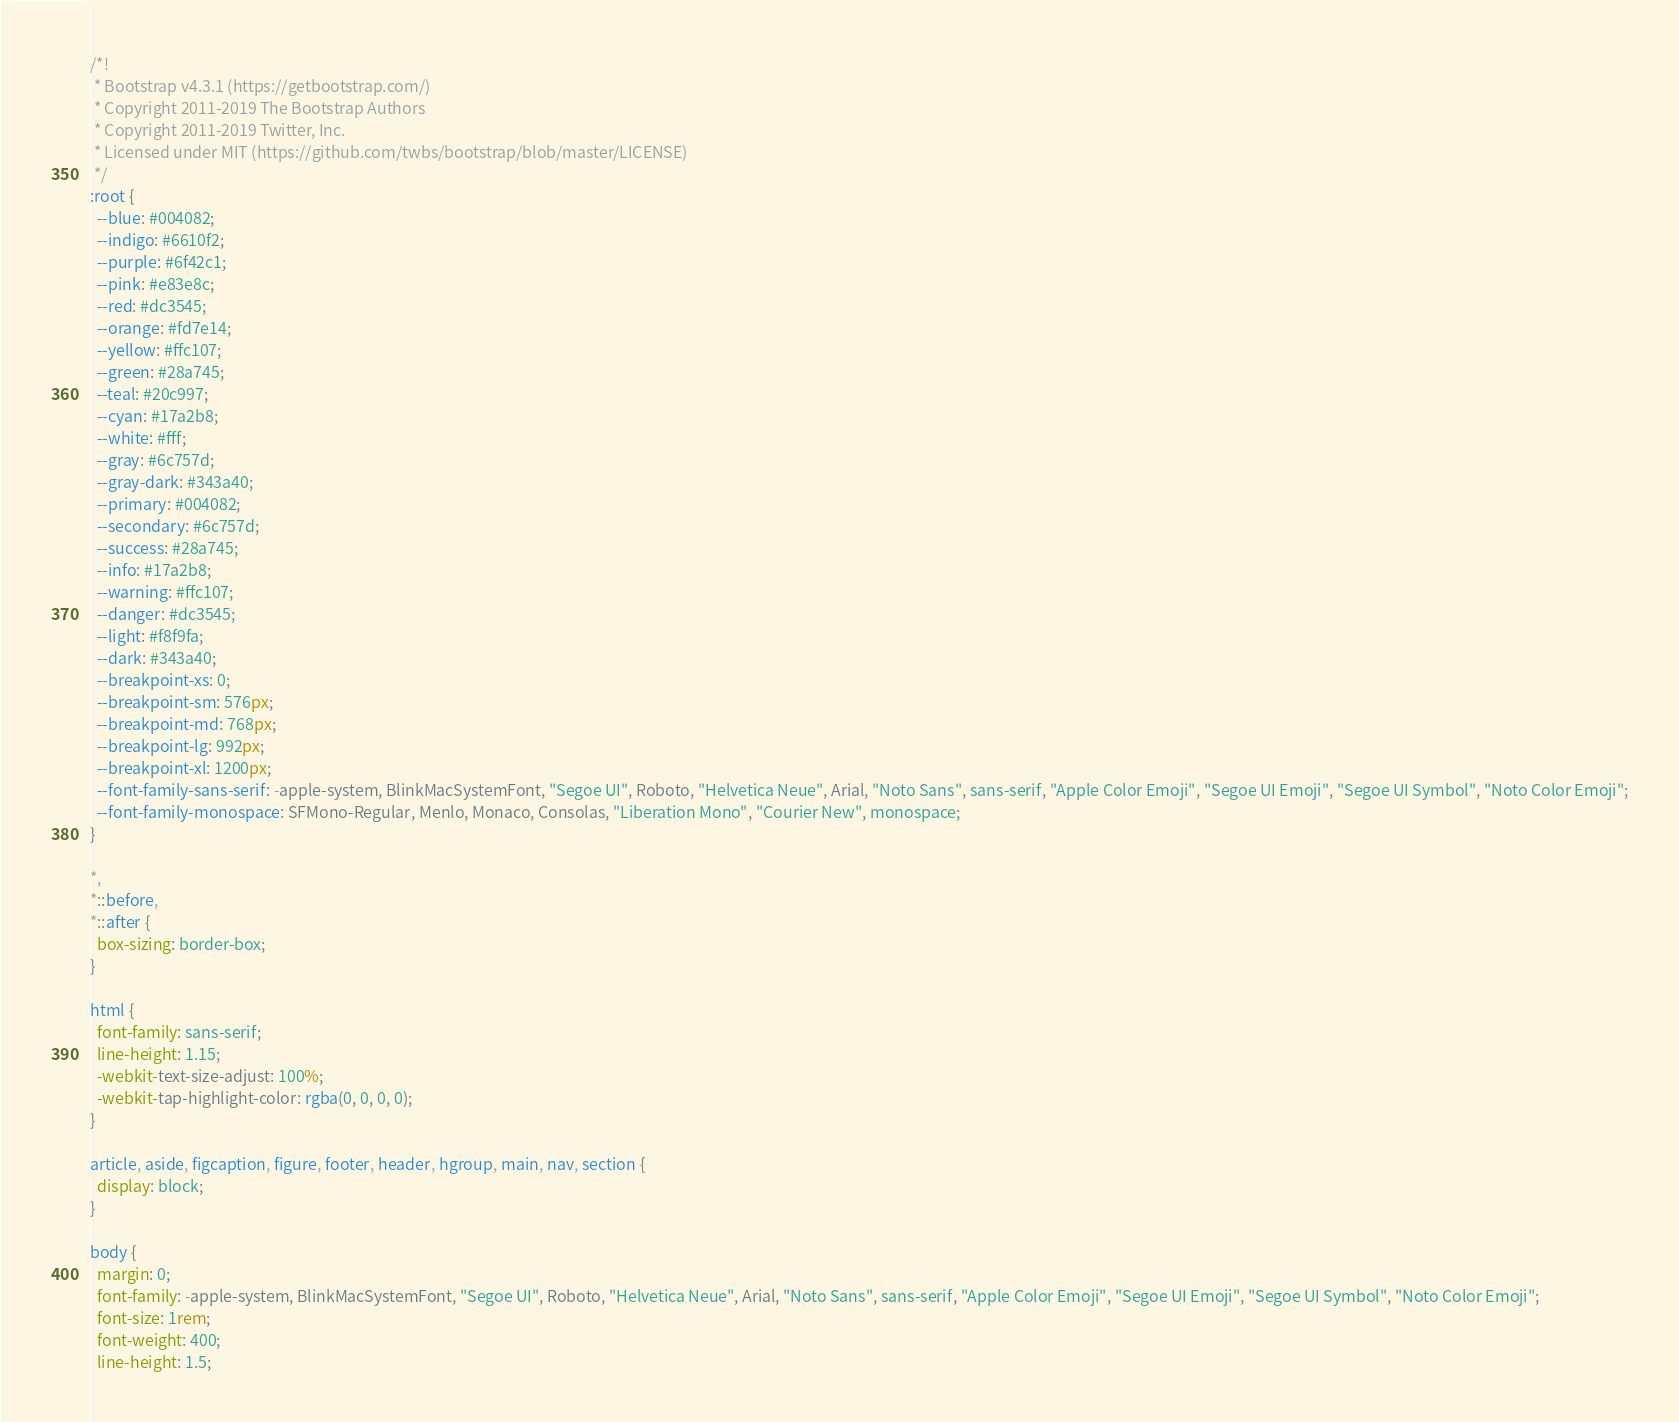Convert code to text. <code><loc_0><loc_0><loc_500><loc_500><_CSS_>/*!
 * Bootstrap v4.3.1 (https://getbootstrap.com/)
 * Copyright 2011-2019 The Bootstrap Authors
 * Copyright 2011-2019 Twitter, Inc.
 * Licensed under MIT (https://github.com/twbs/bootstrap/blob/master/LICENSE)
 */
:root {
  --blue: #004082;
  --indigo: #6610f2;
  --purple: #6f42c1;
  --pink: #e83e8c;
  --red: #dc3545;
  --orange: #fd7e14;
  --yellow: #ffc107;
  --green: #28a745;
  --teal: #20c997;
  --cyan: #17a2b8;
  --white: #fff;
  --gray: #6c757d;
  --gray-dark: #343a40;
  --primary: #004082;
  --secondary: #6c757d;
  --success: #28a745;
  --info: #17a2b8;
  --warning: #ffc107;
  --danger: #dc3545;
  --light: #f8f9fa;
  --dark: #343a40;
  --breakpoint-xs: 0;
  --breakpoint-sm: 576px;
  --breakpoint-md: 768px;
  --breakpoint-lg: 992px;
  --breakpoint-xl: 1200px;
  --font-family-sans-serif: -apple-system, BlinkMacSystemFont, "Segoe UI", Roboto, "Helvetica Neue", Arial, "Noto Sans", sans-serif, "Apple Color Emoji", "Segoe UI Emoji", "Segoe UI Symbol", "Noto Color Emoji";
  --font-family-monospace: SFMono-Regular, Menlo, Monaco, Consolas, "Liberation Mono", "Courier New", monospace;
}

*,
*::before,
*::after {
  box-sizing: border-box;
}

html {
  font-family: sans-serif;
  line-height: 1.15;
  -webkit-text-size-adjust: 100%;
  -webkit-tap-highlight-color: rgba(0, 0, 0, 0);
}

article, aside, figcaption, figure, footer, header, hgroup, main, nav, section {
  display: block;
}

body {
  margin: 0;
  font-family: -apple-system, BlinkMacSystemFont, "Segoe UI", Roboto, "Helvetica Neue", Arial, "Noto Sans", sans-serif, "Apple Color Emoji", "Segoe UI Emoji", "Segoe UI Symbol", "Noto Color Emoji";
  font-size: 1rem;
  font-weight: 400;
  line-height: 1.5;</code> 